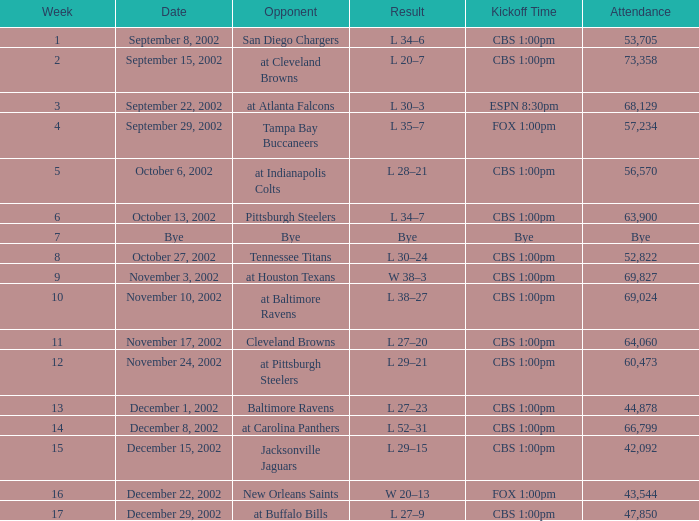I'm looking to parse the entire table for insights. Could you assist me with that? {'header': ['Week', 'Date', 'Opponent', 'Result', 'Kickoff Time', 'Attendance'], 'rows': [['1', 'September 8, 2002', 'San Diego Chargers', 'L 34–6', 'CBS 1:00pm', '53,705'], ['2', 'September 15, 2002', 'at Cleveland Browns', 'L 20–7', 'CBS 1:00pm', '73,358'], ['3', 'September 22, 2002', 'at Atlanta Falcons', 'L 30–3', 'ESPN 8:30pm', '68,129'], ['4', 'September 29, 2002', 'Tampa Bay Buccaneers', 'L 35–7', 'FOX 1:00pm', '57,234'], ['5', 'October 6, 2002', 'at Indianapolis Colts', 'L 28–21', 'CBS 1:00pm', '56,570'], ['6', 'October 13, 2002', 'Pittsburgh Steelers', 'L 34–7', 'CBS 1:00pm', '63,900'], ['7', 'Bye', 'Bye', 'Bye', 'Bye', 'Bye'], ['8', 'October 27, 2002', 'Tennessee Titans', 'L 30–24', 'CBS 1:00pm', '52,822'], ['9', 'November 3, 2002', 'at Houston Texans', 'W 38–3', 'CBS 1:00pm', '69,827'], ['10', 'November 10, 2002', 'at Baltimore Ravens', 'L 38–27', 'CBS 1:00pm', '69,024'], ['11', 'November 17, 2002', 'Cleveland Browns', 'L 27–20', 'CBS 1:00pm', '64,060'], ['12', 'November 24, 2002', 'at Pittsburgh Steelers', 'L 29–21', 'CBS 1:00pm', '60,473'], ['13', 'December 1, 2002', 'Baltimore Ravens', 'L 27–23', 'CBS 1:00pm', '44,878'], ['14', 'December 8, 2002', 'at Carolina Panthers', 'L 52–31', 'CBS 1:00pm', '66,799'], ['15', 'December 15, 2002', 'Jacksonville Jaguars', 'L 29–15', 'CBS 1:00pm', '42,092'], ['16', 'December 22, 2002', 'New Orleans Saints', 'W 20–13', 'FOX 1:00pm', '43,544'], ['17', 'December 29, 2002', 'at Buffalo Bills', 'L 27–9', 'CBS 1:00pm', '47,850']]} In what week number did the launch time cbs 1:00pm occur, with 60,473 people attending? 1.0. 